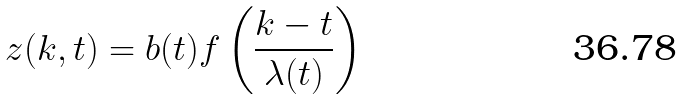Convert formula to latex. <formula><loc_0><loc_0><loc_500><loc_500>z ( k , t ) = b ( t ) f \left ( \frac { k - t } { \lambda ( t ) } \right )</formula> 